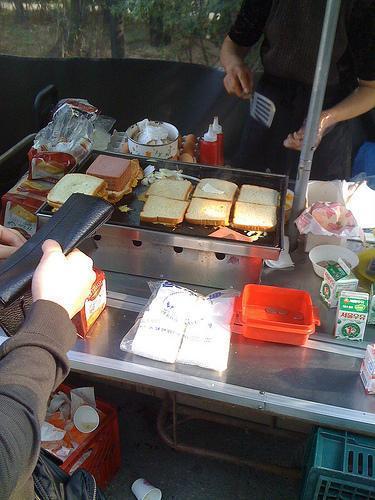How many people are shown buying food?
Give a very brief answer. 1. 